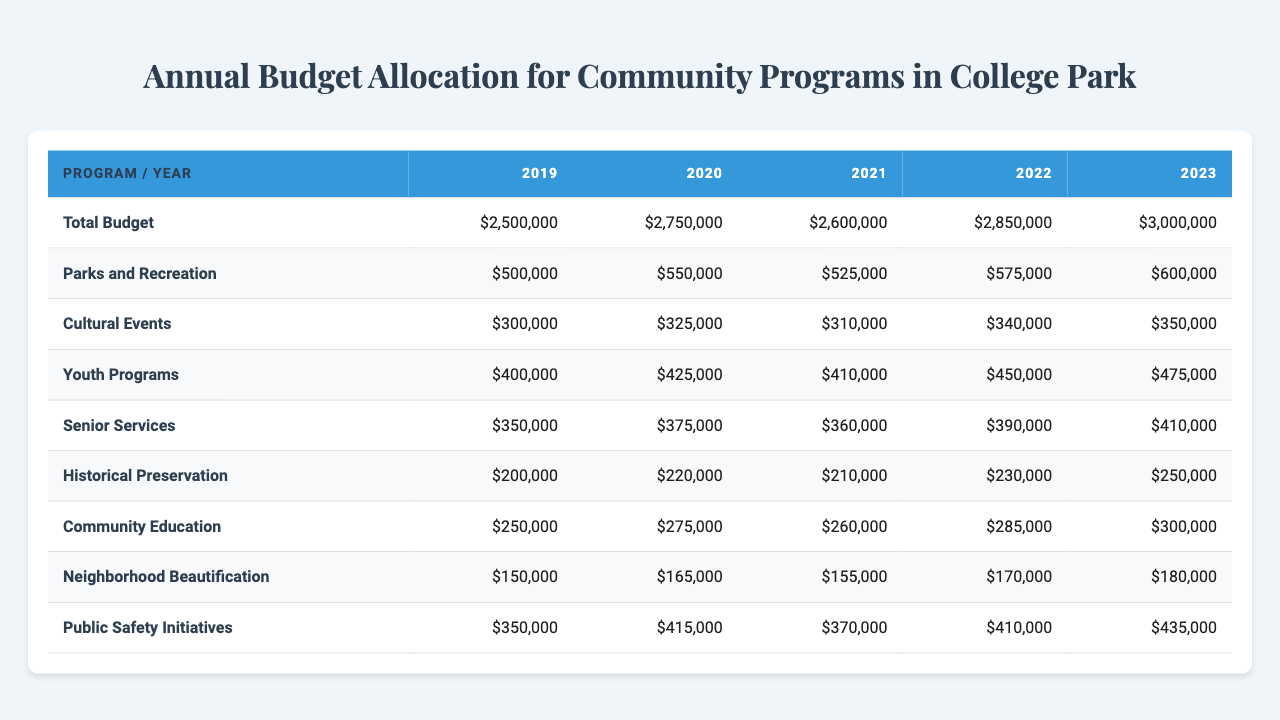What is the total budget for the fiscal year 2023? The table shows a specific row for the total budget, and for the fiscal year 2023, the value listed is $3,000,000.
Answer: $3,000,000 How much money was allocated to Parks and Recreation in 2020? In the row for Parks and Recreation, the budget for the year 2020 specifically states $550,000.
Answer: $550,000 What was the increase in funding for Public Safety Initiatives from 2019 to 2023? The funding for 2019 was $350,000 and for 2023 it is $435,000. The increase is calculated by subtracting the earlier value from the latter: $435,000 - $350,000 = $85,000.
Answer: $85,000 What is the total budget allocated for Youth Programs across all years? The funding amounts for Youth Programs are $400,000 (2019), $425,000 (2020), $410,000 (2021), $450,000 (2022), and $475,000 (2023). Summing these gives $400,000 + $425,000 + $410,000 + $450,000 + $475,000 = $2,160,000.
Answer: $2,160,000 Which program received the most funding in the fiscal year 2022? By comparing the amounts for each program in 2022, we find that Parks and Recreation, with $575,000, received the highest funding among all programs listed for that year.
Answer: Parks and Recreation Did the allocation for Cultural Events increase in 2021 compared to 2020? The funding for Cultural Events in 2020 was $325,000, and in 2021 it decreased to $310,000. Thus, this statement is false.
Answer: No What is the average budget allocated to Historical Preservation over the five years? The funding amounts for Historical Preservation are $200,000 (2019), $220,000 (2020), $210,000 (2021), $230,000 (2022), and $250,000 (2023). The total is $200,000 + $220,000 + $210,000 + $230,000 + $250,000 = $1,110,000. Dividing by 5 gives an average of $1,110,000 / 5 = $222,000.
Answer: $222,000 How much more was spent on Community Education in 2023 compared to 2019? The budget for Community Education in 2019 was $250,000 and in 2023 it is $300,000. The difference is $300,000 - $250,000 = $50,000.
Answer: $50,000 What is the total amount allocated for Senior Services from 2019 to 2023? The values for Senior Services are $350,000 (2019), $375,000 (2020), $360,000 (2021), $390,000 (2022), and $410,000 (2023). Summing these gives $350,000 + $375,000 + $360,000 + $390,000 + $410,000 = $1,885,000.
Answer: $1,885,000 Is the budget allocated for Neighborhood Beautification greater than that for Historical Preservation in 2022? In 2022, Neighborhood Beautification received $170,000 and Historical Preservation received $230,000. Since $170,000 < $230,000, the statement is false.
Answer: No 